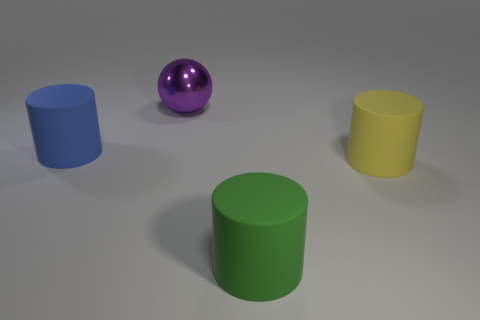Add 2 blue matte objects. How many objects exist? 6 Subtract all yellow cylinders. How many cylinders are left? 2 Subtract all cylinders. How many objects are left? 1 Subtract 1 balls. How many balls are left? 0 Subtract all brown balls. How many yellow cylinders are left? 1 Subtract all small rubber cubes. Subtract all yellow cylinders. How many objects are left? 3 Add 3 metallic things. How many metallic things are left? 4 Add 2 small blue metal cubes. How many small blue metal cubes exist? 2 Subtract 0 cyan cylinders. How many objects are left? 4 Subtract all cyan cylinders. Subtract all red spheres. How many cylinders are left? 3 